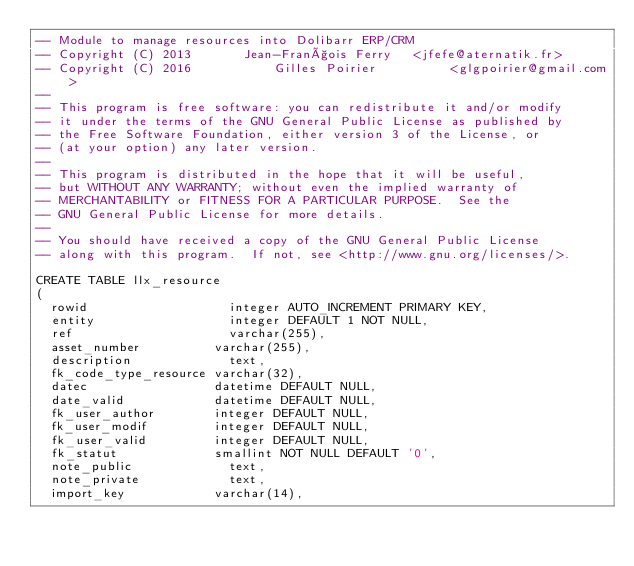Convert code to text. <code><loc_0><loc_0><loc_500><loc_500><_SQL_>-- Module to manage resources into Dolibarr ERP/CRM
-- Copyright (C) 2013       Jean-François Ferry   <jfefe@aternatik.fr>
-- Copyright (C) 2016		    Gilles Poirier		    <glgpoirier@gmail.com>
--
-- This program is free software: you can redistribute it and/or modify
-- it under the terms of the GNU General Public License as published by
-- the Free Software Foundation, either version 3 of the License, or
-- (at your option) any later version.
--
-- This program is distributed in the hope that it will be useful,
-- but WITHOUT ANY WARRANTY; without even the implied warranty of
-- MERCHANTABILITY or FITNESS FOR A PARTICULAR PURPOSE.  See the
-- GNU General Public License for more details.
--
-- You should have received a copy of the GNU General Public License
-- along with this program.  If not, see <http://www.gnu.org/licenses/>.

CREATE TABLE llx_resource
(
  rowid           		  integer AUTO_INCREMENT PRIMARY KEY,
  entity          		  integer DEFAULT 1 NOT NULL,
  ref             		  varchar(255),
  asset_number          varchar(255),
  description     		  text,
  fk_code_type_resource varchar(32),
  datec                 datetime DEFAULT NULL,
  date_valid            datetime DEFAULT NULL,
  fk_user_author        integer DEFAULT NULL,
  fk_user_modif         integer DEFAULT NULL,
  fk_user_valid         integer DEFAULT NULL,
  fk_statut             smallint NOT NULL DEFAULT '0',
  note_public     		  text,
  note_private    		  text,
  import_key			varchar(14),</code> 